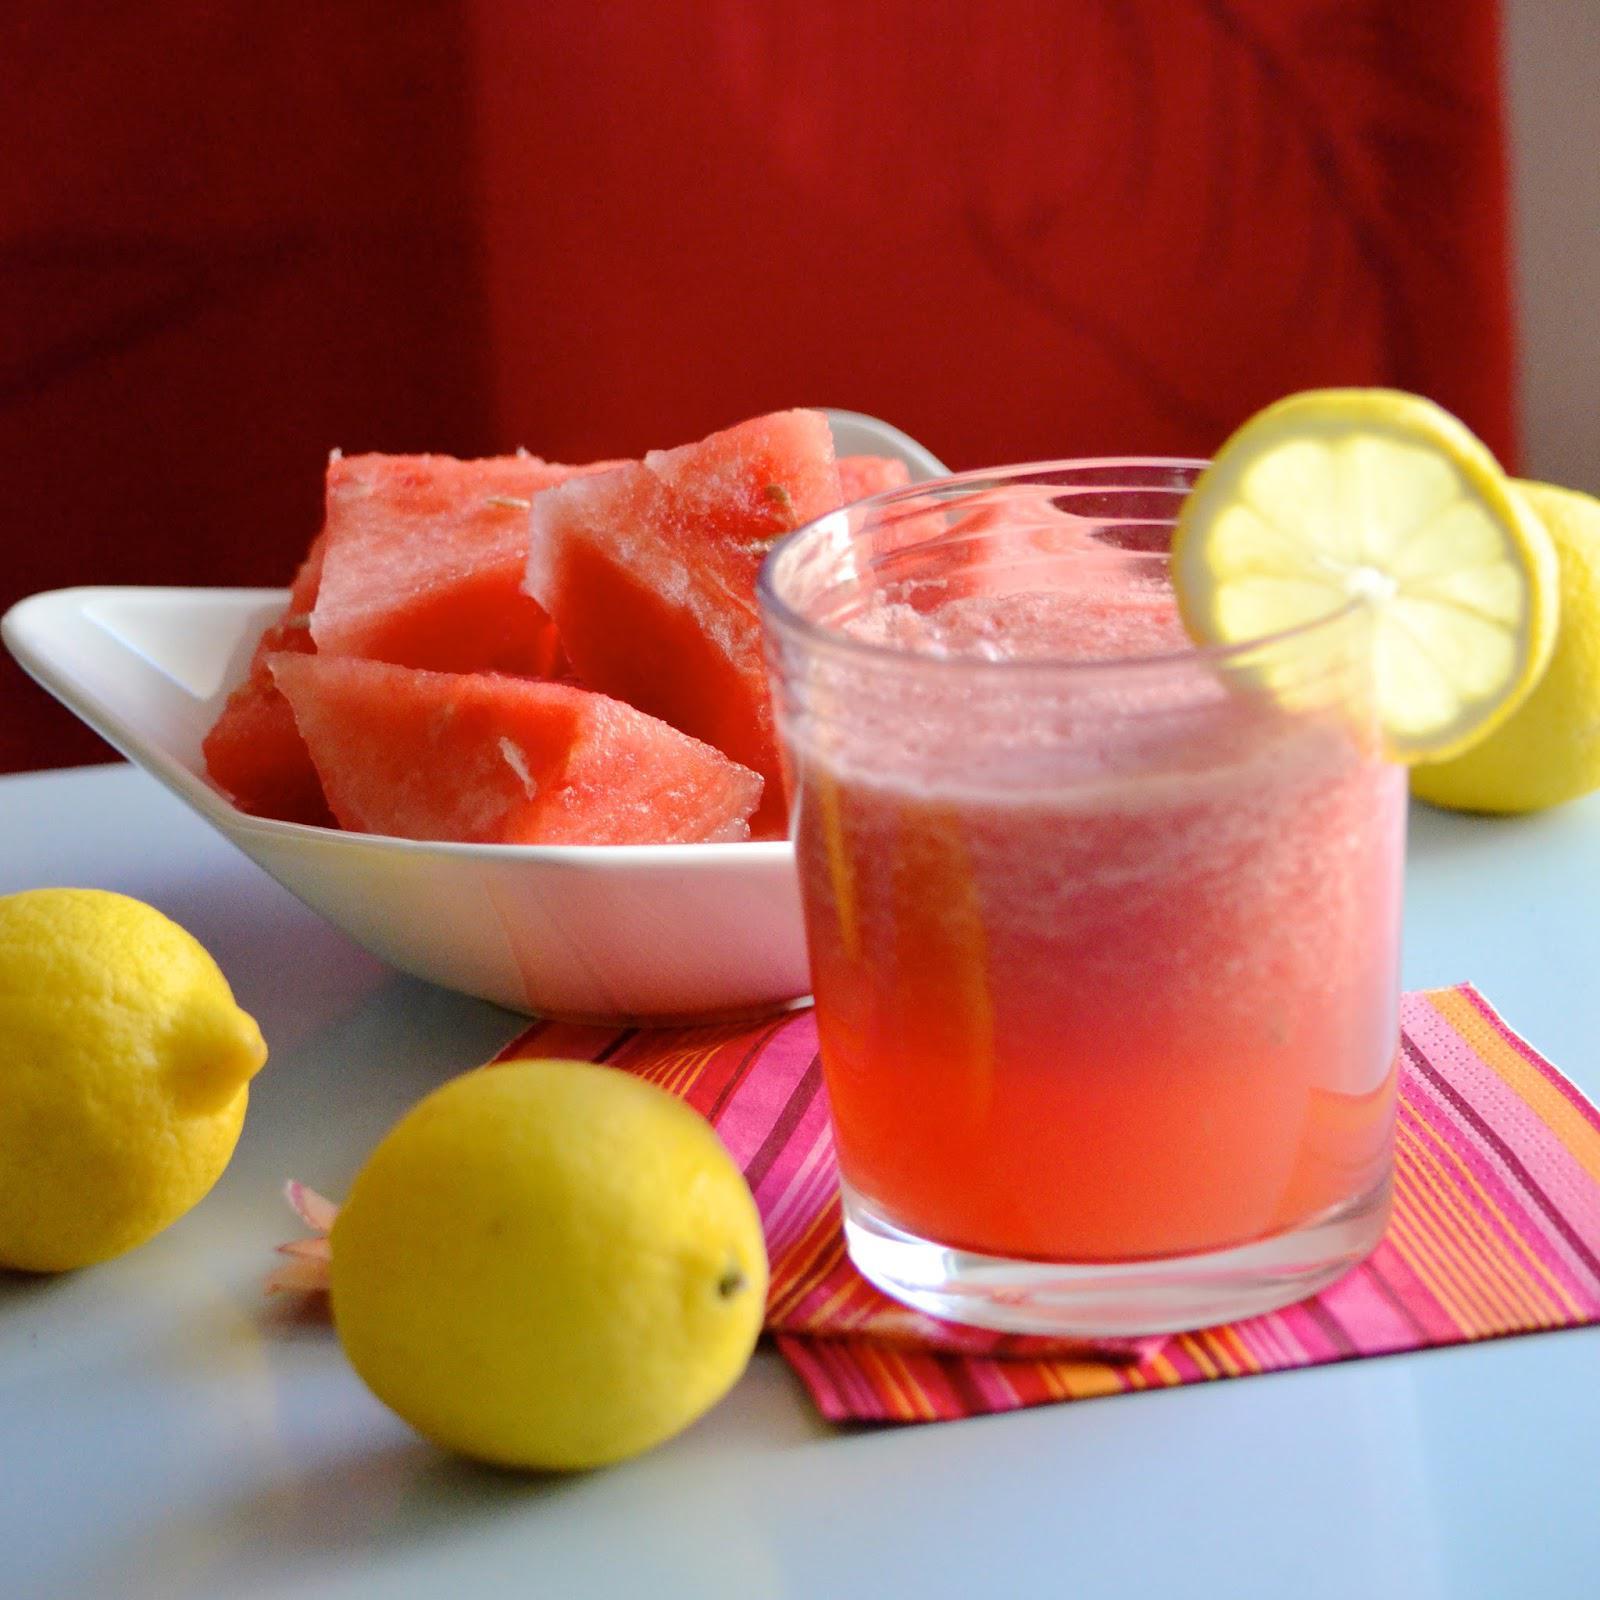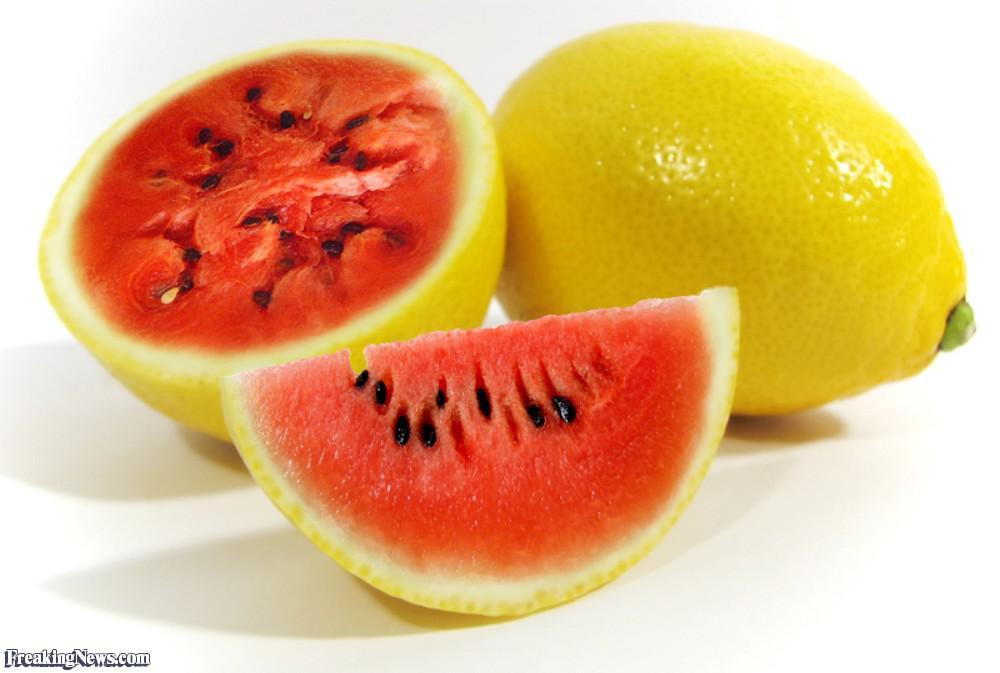The first image is the image on the left, the second image is the image on the right. Examine the images to the left and right. Is the description "There is exactly one full lemon in the image on the right." accurate? Answer yes or no. Yes. 